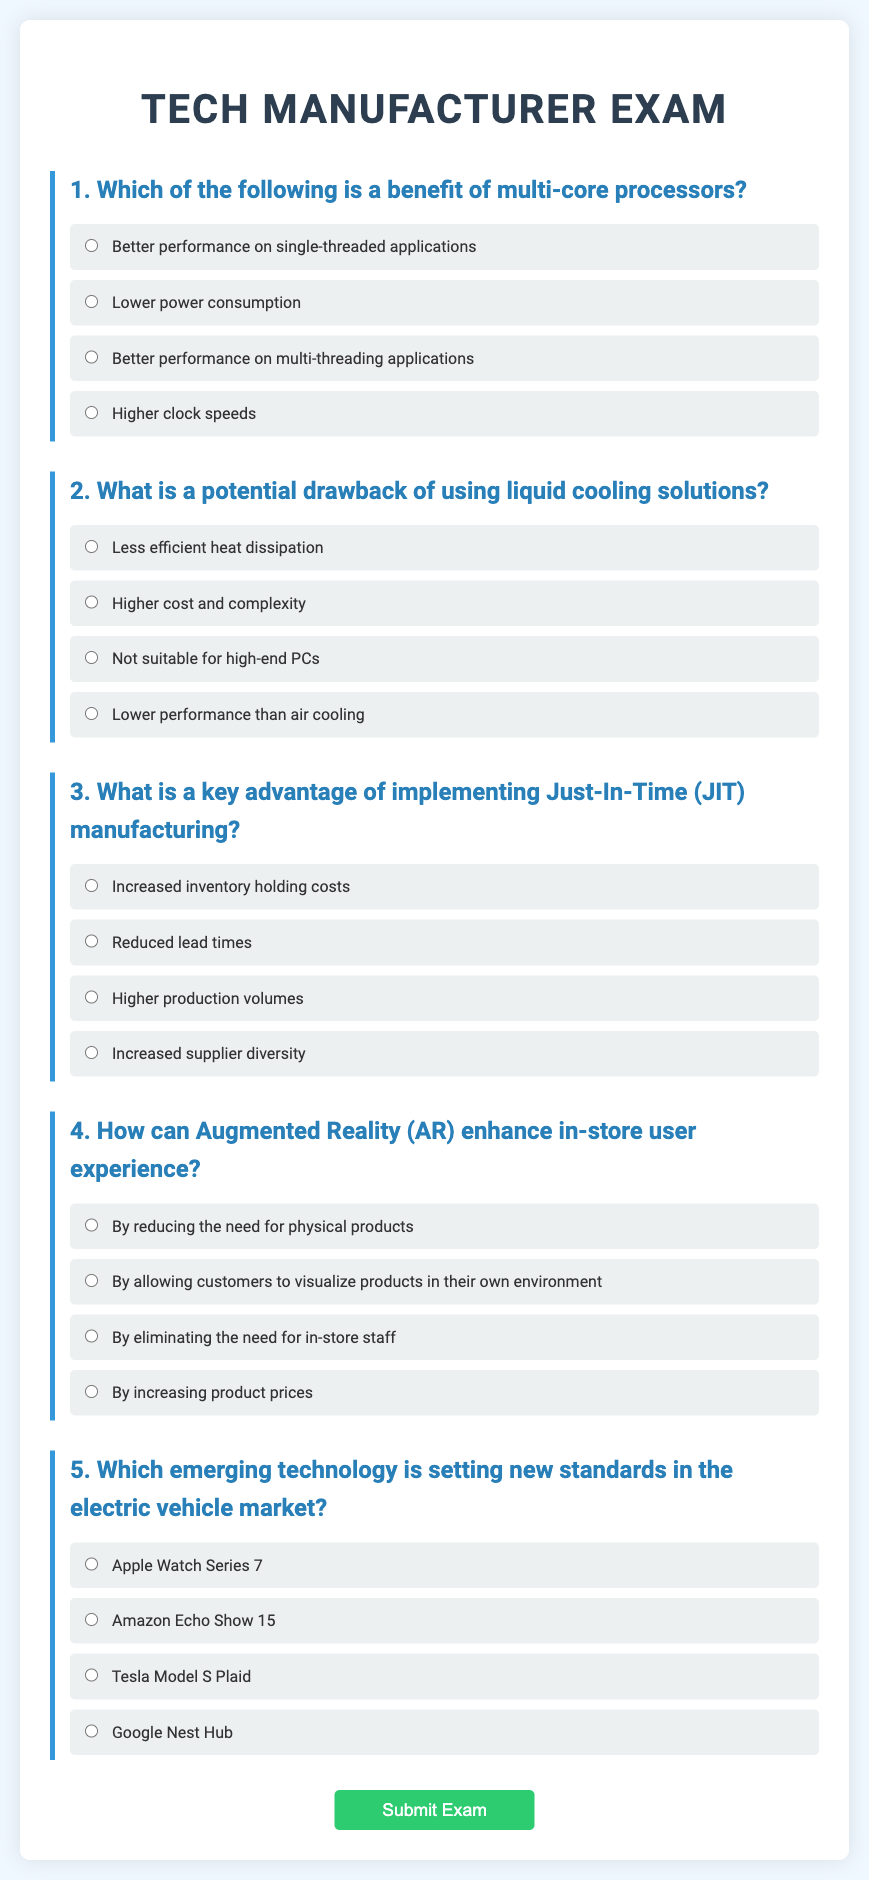Which question is about multi-core processors? The question discussing the benefits of multi-core processors is the first one listed in the document.
Answer: Better performance on multi-threading applications What is the main drawback of liquid cooling solutions? The second question asks about the potential drawbacks of liquid cooling solutions and offers several options.
Answer: Higher cost and complexity What advantage does Just-In-Time manufacturing provide? The third question investigates the benefits of implementing Just-In-Time manufacturing, focusing on lead times.
Answer: Reduced lead times How does Augmented Reality enhance user experience? The fourth question examines how Augmented Reality can improve the in-store experience for customers.
Answer: By allowing customers to visualize products in their own environment Which emerging technology is discussed in relation to the electric vehicle market? The fifth question identifies which technology is setting new standards within the specified market.
Answer: Tesla Model S Plaid 